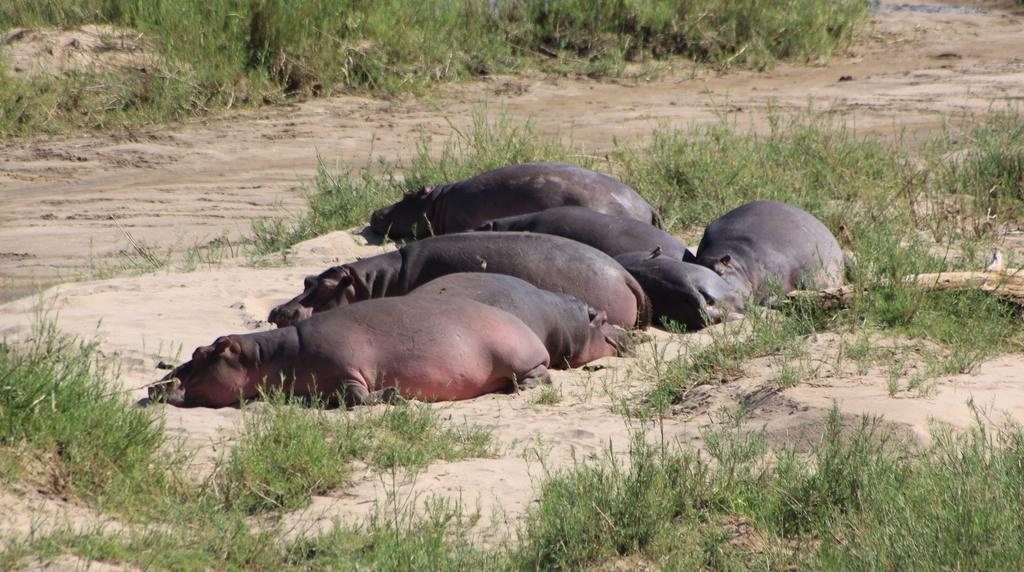What animals can be seen lying on the ground in the image? There are hippopotamuses lying on the ground in the image. What type of vegetation is visible at the top of the image? Grass is visible at the top of the image. What type of terrain is present in the middle of the image? Soil is present in the middle of the image. What type of sticks can be seen in the image? There are no sticks present in the image. How does the image depict the front of the hippopotamuses? The image does not show the front of the hippopotamuses; it only shows them lying on the ground. 